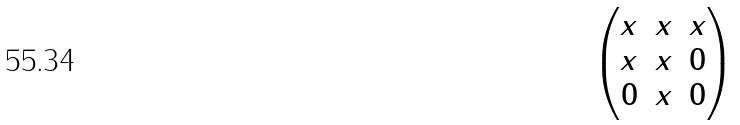Convert formula to latex. <formula><loc_0><loc_0><loc_500><loc_500>\begin{pmatrix} x & x & x \\ x & x & 0 \\ 0 & x & 0 \\ \end{pmatrix}</formula> 